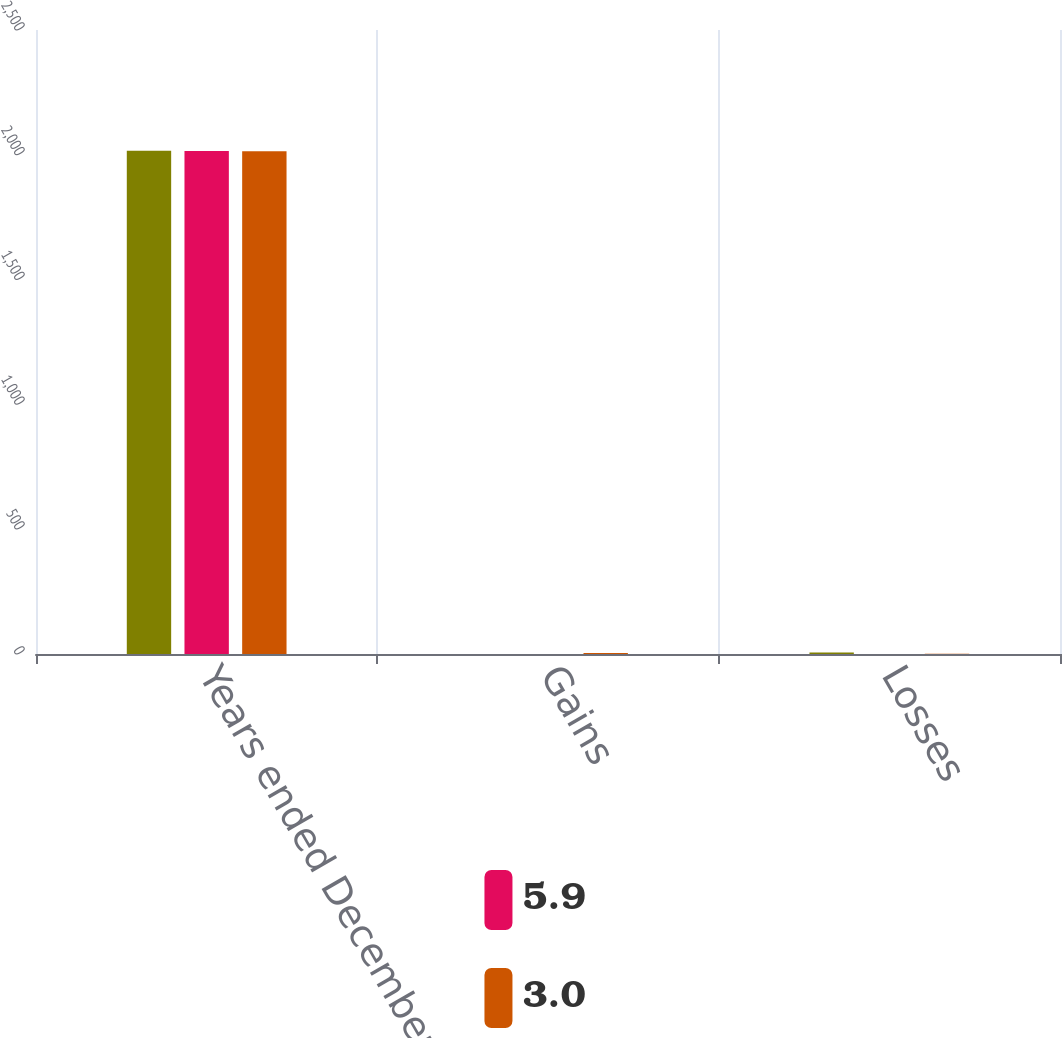<chart> <loc_0><loc_0><loc_500><loc_500><stacked_bar_chart><ecel><fcel>Years ended December 31 (in<fcel>Gains<fcel>Losses<nl><fcel>nan<fcel>2016<fcel>0.2<fcel>6.1<nl><fcel>5.9<fcel>2015<fcel>0.3<fcel>0.3<nl><fcel>3<fcel>2014<fcel>4.4<fcel>1.4<nl></chart> 